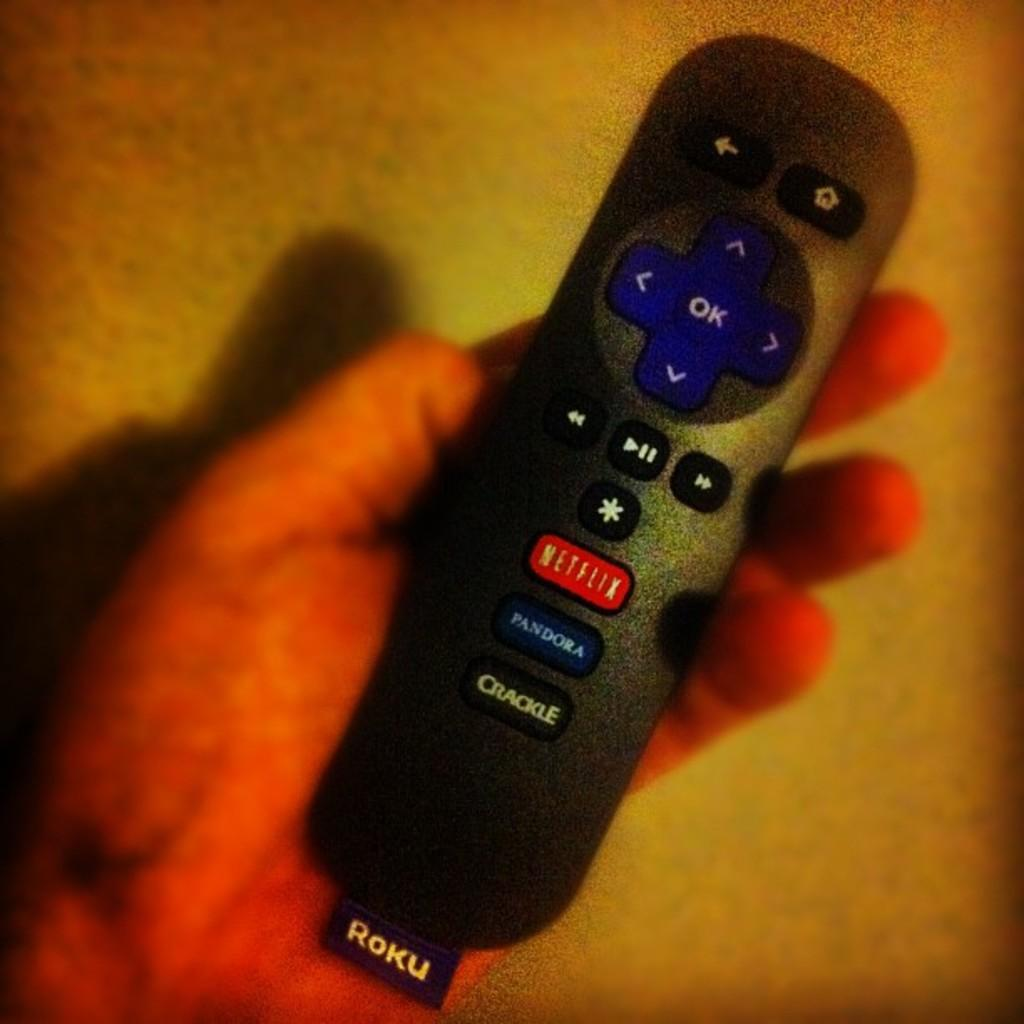<image>
Share a concise interpretation of the image provided. A Roku TV remote control with buttons for Netflix, Pandora and Crackle. 